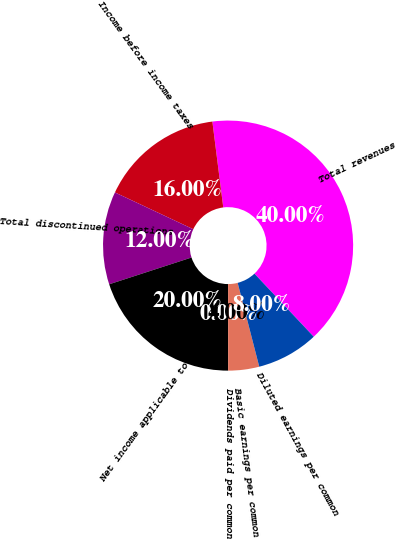Convert chart to OTSL. <chart><loc_0><loc_0><loc_500><loc_500><pie_chart><fcel>Total revenues<fcel>Income before income taxes<fcel>Total discontinued operations<fcel>Net income applicable to<fcel>Dividends paid per common<fcel>Basic earnings per common<fcel>Diluted earnings per common<nl><fcel>40.0%<fcel>16.0%<fcel>12.0%<fcel>20.0%<fcel>0.0%<fcel>4.0%<fcel>8.0%<nl></chart> 